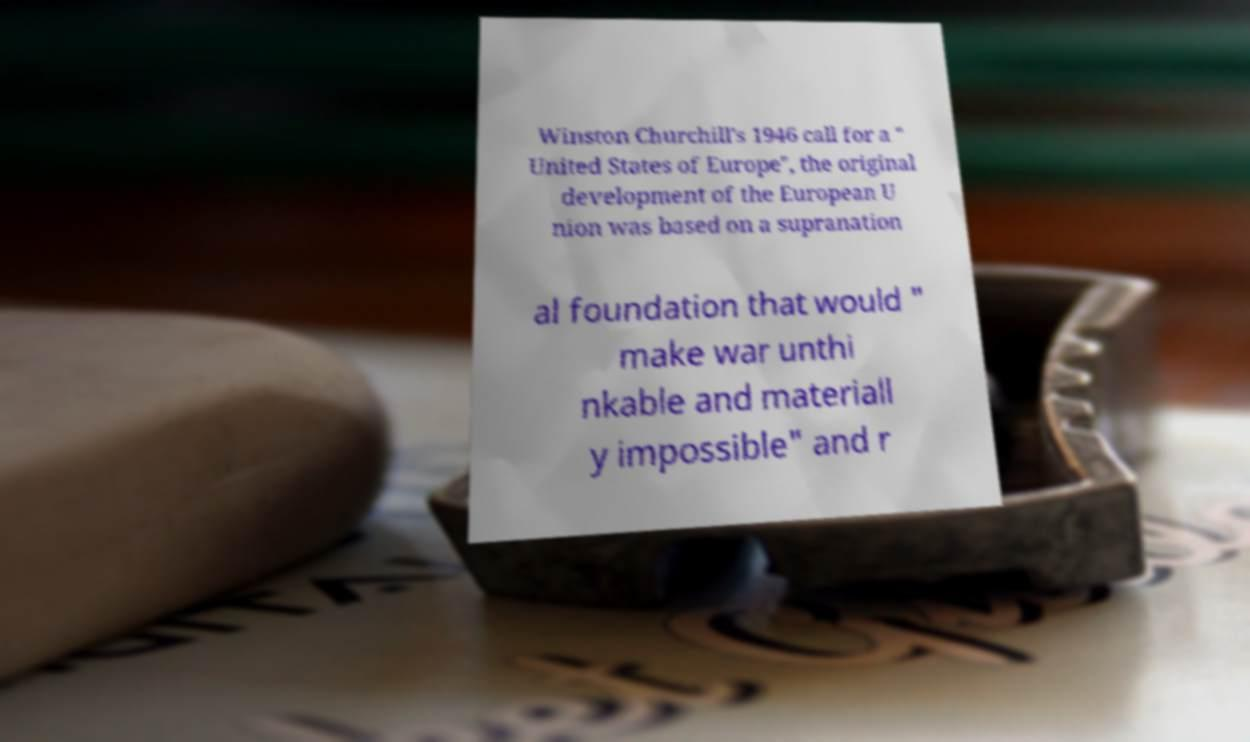I need the written content from this picture converted into text. Can you do that? Winston Churchill's 1946 call for a " United States of Europe", the original development of the European U nion was based on a supranation al foundation that would " make war unthi nkable and materiall y impossible" and r 